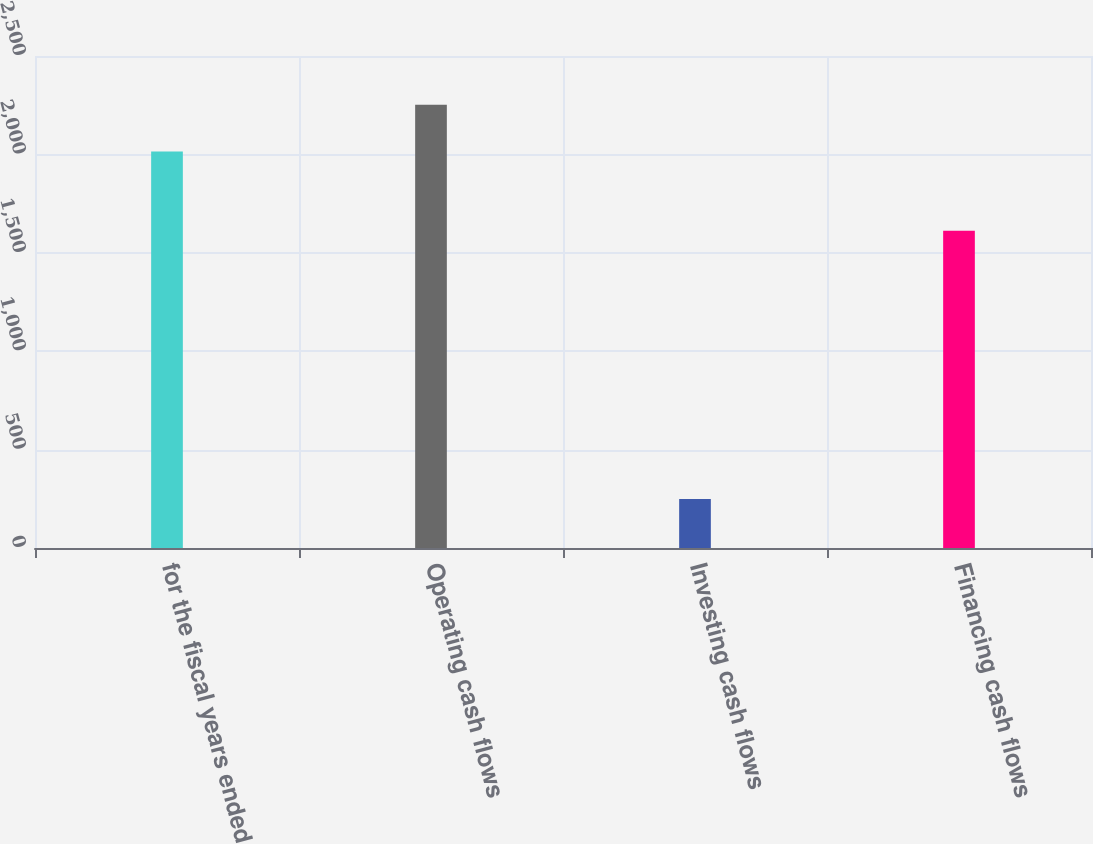Convert chart to OTSL. <chart><loc_0><loc_0><loc_500><loc_500><bar_chart><fcel>for the fiscal years ended<fcel>Operating cash flows<fcel>Investing cash flows<fcel>Financing cash flows<nl><fcel>2015<fcel>2252<fcel>248.9<fcel>1612.2<nl></chart> 